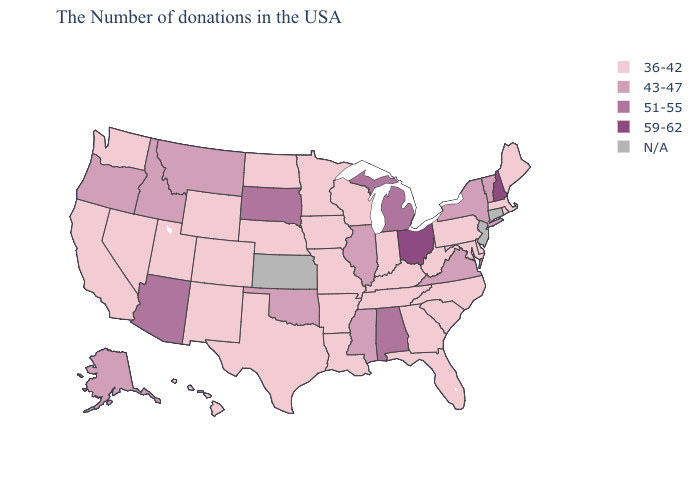Among the states that border Minnesota , which have the lowest value?
Keep it brief. Wisconsin, Iowa, North Dakota. How many symbols are there in the legend?
Concise answer only. 5. What is the highest value in states that border Arizona?
Give a very brief answer. 36-42. Among the states that border New Hampshire , does Vermont have the lowest value?
Write a very short answer. No. Name the states that have a value in the range 36-42?
Concise answer only. Maine, Massachusetts, Rhode Island, Delaware, Maryland, Pennsylvania, North Carolina, South Carolina, West Virginia, Florida, Georgia, Kentucky, Indiana, Tennessee, Wisconsin, Louisiana, Missouri, Arkansas, Minnesota, Iowa, Nebraska, Texas, North Dakota, Wyoming, Colorado, New Mexico, Utah, Nevada, California, Washington, Hawaii. What is the value of Missouri?
Keep it brief. 36-42. Among the states that border Iowa , which have the highest value?
Short answer required. South Dakota. What is the value of Alabama?
Short answer required. 51-55. What is the value of Rhode Island?
Concise answer only. 36-42. Name the states that have a value in the range N/A?
Quick response, please. Connecticut, New Jersey, Kansas. Does Oregon have the lowest value in the USA?
Keep it brief. No. Name the states that have a value in the range 59-62?
Be succinct. New Hampshire, Ohio. Which states have the highest value in the USA?
Answer briefly. New Hampshire, Ohio. Name the states that have a value in the range N/A?
Give a very brief answer. Connecticut, New Jersey, Kansas. Does Michigan have the highest value in the USA?
Short answer required. No. 